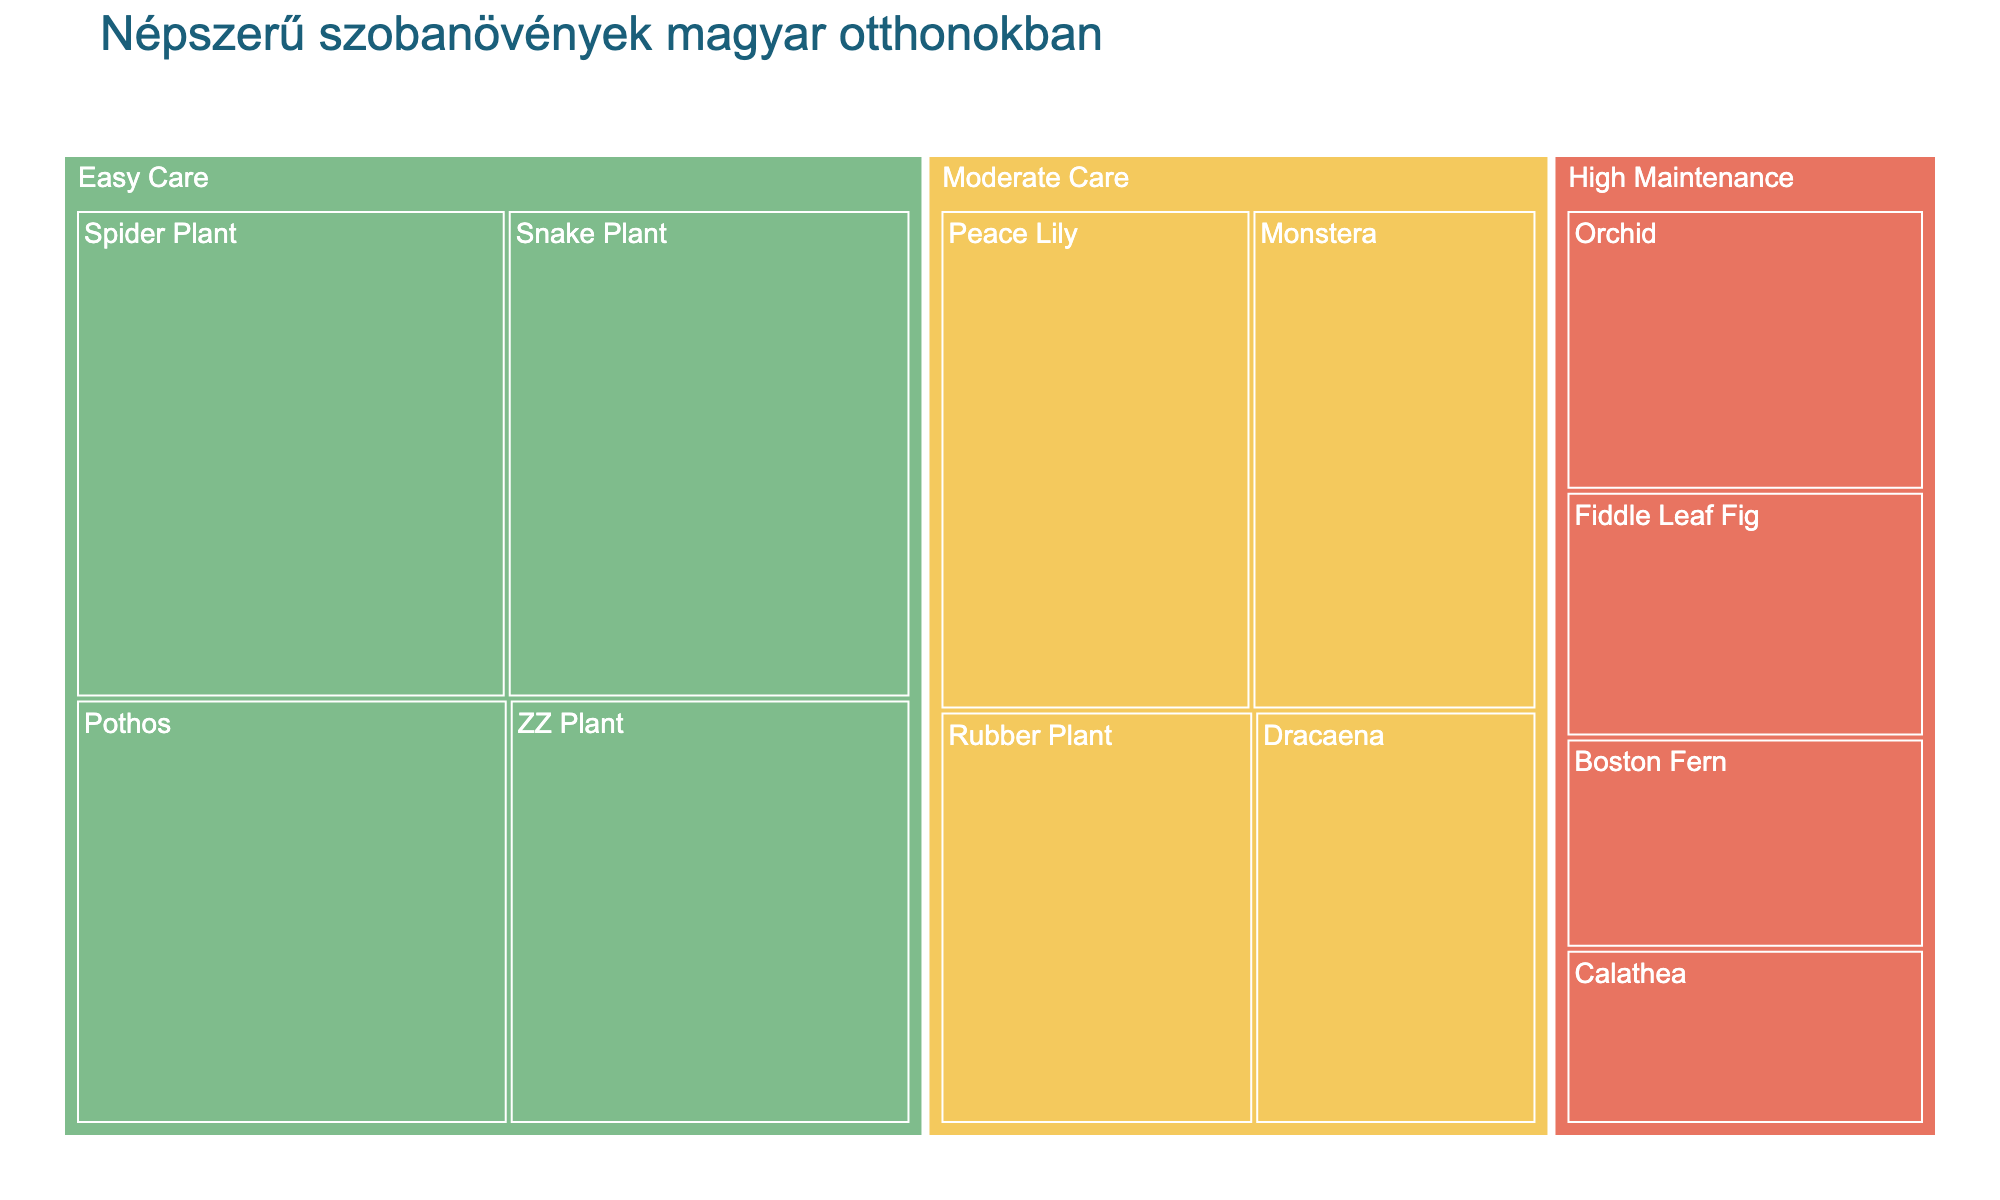Which houseplant has the highest popularity? By looking at the sizes of the sections in the treemap, we can see that the biggest section represents the Spider Plant. Its popularity value is the highest at 80.
Answer: Spider Plant Which care level category has the most popular plants combined? We need to sum up the popularity values for each care level category. For Easy Care (80 + 75 + 70 + 65 = 290), Moderate Care (60 + 55 + 50 + 45 = 210), and High Maintenance (40 + 35 + 30 + 25 = 130). Easy Care has the highest total.
Answer: Easy Care What is the location of the least popular houseplant? We need to find the section in the treemap with the smallest value. The smallest section represents Calathea with a popularity of 25, and its location is the Bedroom.
Answer: Bedroom How does the popularity of Snake Plant compare to Dracaena? Referring to the size of the sections in the treemap, Snake Plant has a popularity value of 75, while Dracaena has 45. 75 is greater than 45.
Answer: Snake Plant is more popular Which houseplant in the bathroom has the highest popularity? From the treemap, we see two houseplants located in the bathroom: Peace Lily with a popularity of 60 and Boston Fern with a popularity of 30. Peace Lily is higher.
Answer: Peace Lily What percentage of the total popularity does ZZ Plant hold? First, sum the total popularity values (80 + 75 + 70 + 65 + 60 + 55 + 50 + 45 + 40 + 35 + 30 + 25 = 630). Then, calculate the percentage for ZZ Plant (65 / 630 * 100 = ~10.32%).
Answer: ~10.32% Which category has a greater sum of popularities: Moderate Care Peace Lily and Monstera combined, or High Maintenance Orchid and Fiddle Leaf Fig combined? Calculate the sums: Peace Lily (60) + Monstera (55) = 115; Orchid (40) + Fiddle Leaf Fig (35) = 75. Moderate Care is higher.
Answer: Moderate Care What is the popularity difference between Pothos and the least popular plant? Pothos has a popularity of 70, and the least popular plant is Calathea with 25. The difference is 70 - 25 = 45.
Answer: 45 Which color represents the High Maintenance care level? By referring to the color legend in the treemap, High Maintenance plants are represented by the color red (#E87461).
Answer: Red 